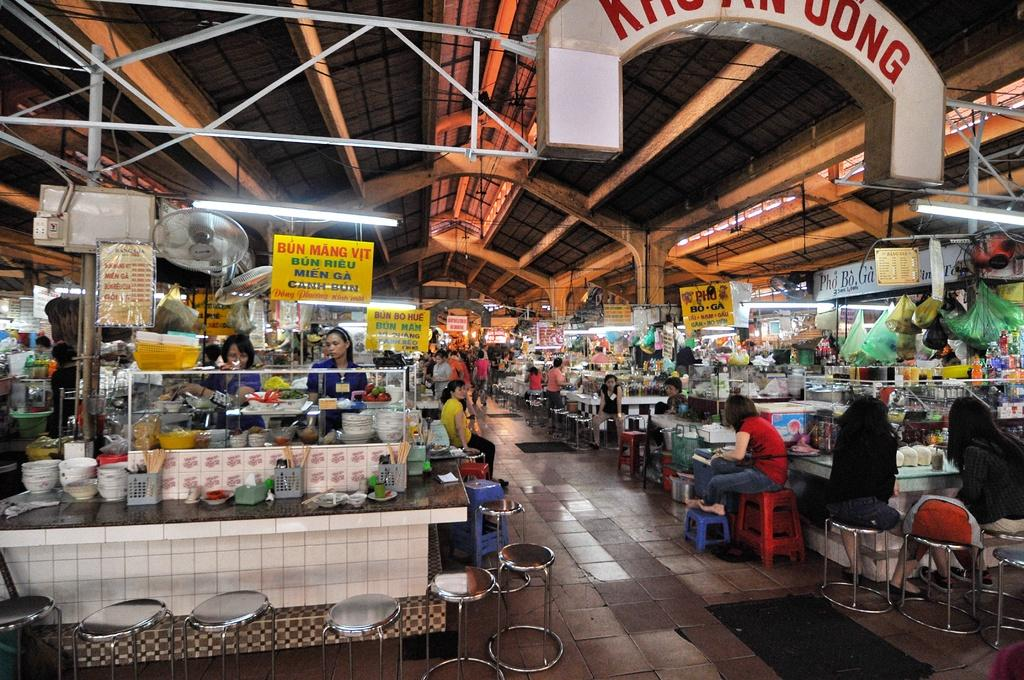Provide a one-sentence caption for the provided image. A market with several stalls and the yellow sign high on the left says Bun Mang Vit. 